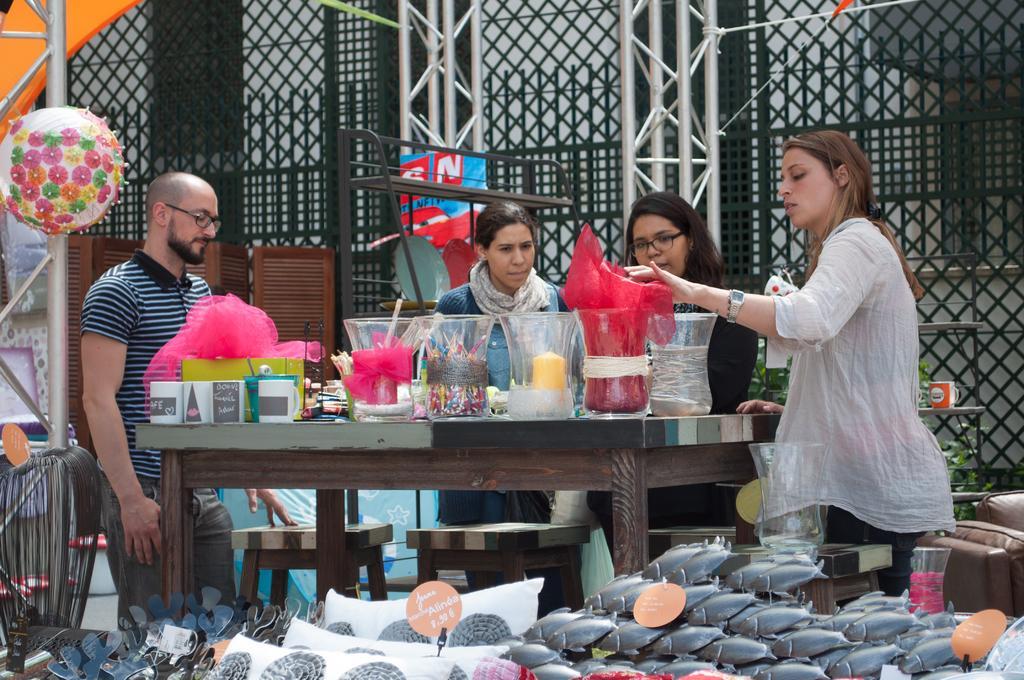How would you summarize this image in a sentence or two? In the image we can see there are three women and a man standing, they are wearing clothes and some of them are wearing spectacles. There is a table, on the table there are many other things and a plastic cover. There are even stools and a sofa, this is a fence, plant, decorative balloon and other objects. 